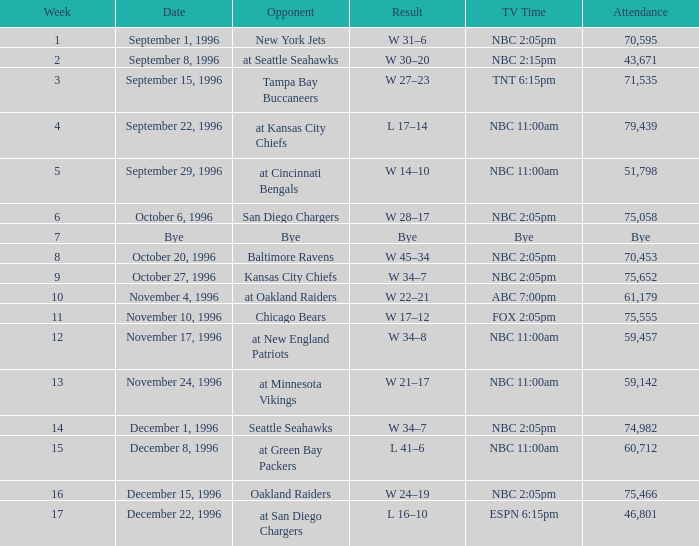What is the television duration exceeding a week by 15, featuring the oakland raiders as an adversary? NBC 2:05pm. Can you parse all the data within this table? {'header': ['Week', 'Date', 'Opponent', 'Result', 'TV Time', 'Attendance'], 'rows': [['1', 'September 1, 1996', 'New York Jets', 'W 31–6', 'NBC 2:05pm', '70,595'], ['2', 'September 8, 1996', 'at Seattle Seahawks', 'W 30–20', 'NBC 2:15pm', '43,671'], ['3', 'September 15, 1996', 'Tampa Bay Buccaneers', 'W 27–23', 'TNT 6:15pm', '71,535'], ['4', 'September 22, 1996', 'at Kansas City Chiefs', 'L 17–14', 'NBC 11:00am', '79,439'], ['5', 'September 29, 1996', 'at Cincinnati Bengals', 'W 14–10', 'NBC 11:00am', '51,798'], ['6', 'October 6, 1996', 'San Diego Chargers', 'W 28–17', 'NBC 2:05pm', '75,058'], ['7', 'Bye', 'Bye', 'Bye', 'Bye', 'Bye'], ['8', 'October 20, 1996', 'Baltimore Ravens', 'W 45–34', 'NBC 2:05pm', '70,453'], ['9', 'October 27, 1996', 'Kansas City Chiefs', 'W 34–7', 'NBC 2:05pm', '75,652'], ['10', 'November 4, 1996', 'at Oakland Raiders', 'W 22–21', 'ABC 7:00pm', '61,179'], ['11', 'November 10, 1996', 'Chicago Bears', 'W 17–12', 'FOX 2:05pm', '75,555'], ['12', 'November 17, 1996', 'at New England Patriots', 'W 34–8', 'NBC 11:00am', '59,457'], ['13', 'November 24, 1996', 'at Minnesota Vikings', 'W 21–17', 'NBC 11:00am', '59,142'], ['14', 'December 1, 1996', 'Seattle Seahawks', 'W 34–7', 'NBC 2:05pm', '74,982'], ['15', 'December 8, 1996', 'at Green Bay Packers', 'L 41–6', 'NBC 11:00am', '60,712'], ['16', 'December 15, 1996', 'Oakland Raiders', 'W 24–19', 'NBC 2:05pm', '75,466'], ['17', 'December 22, 1996', 'at San Diego Chargers', 'L 16–10', 'ESPN 6:15pm', '46,801']]} 